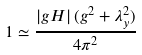Convert formula to latex. <formula><loc_0><loc_0><loc_500><loc_500>1 \simeq \frac { \left | g H \right | ( g ^ { 2 } + \lambda _ { y } ^ { 2 } ) } { 4 \pi ^ { 2 } }</formula> 